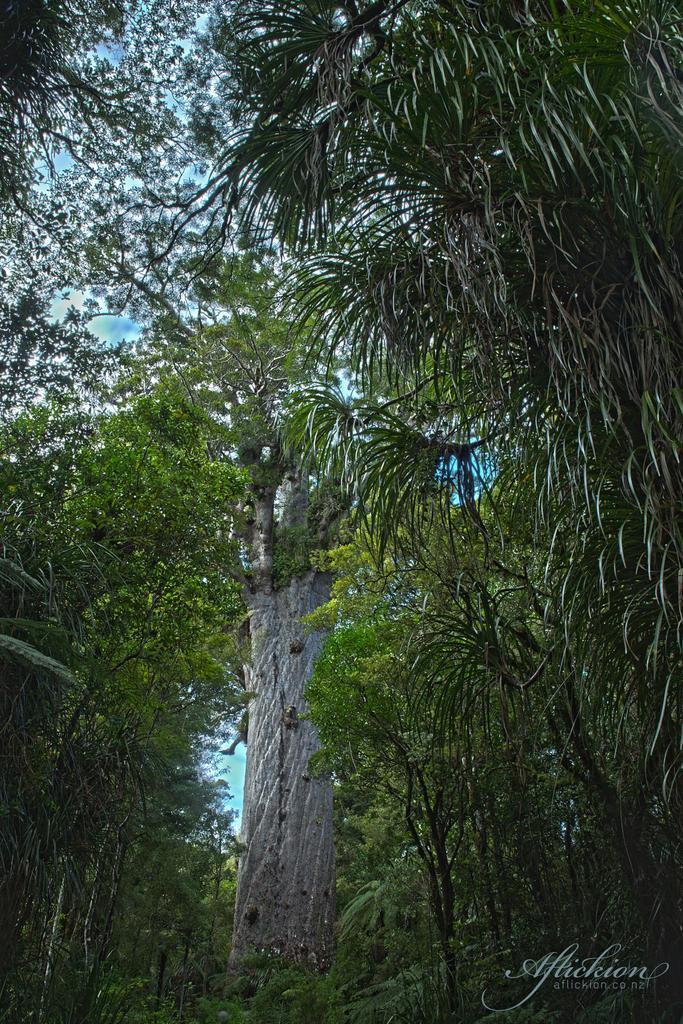Please provide a concise description of this image. In this picture we can see the sky, trees. In the bottom right corner of the picture we can see watermark. 